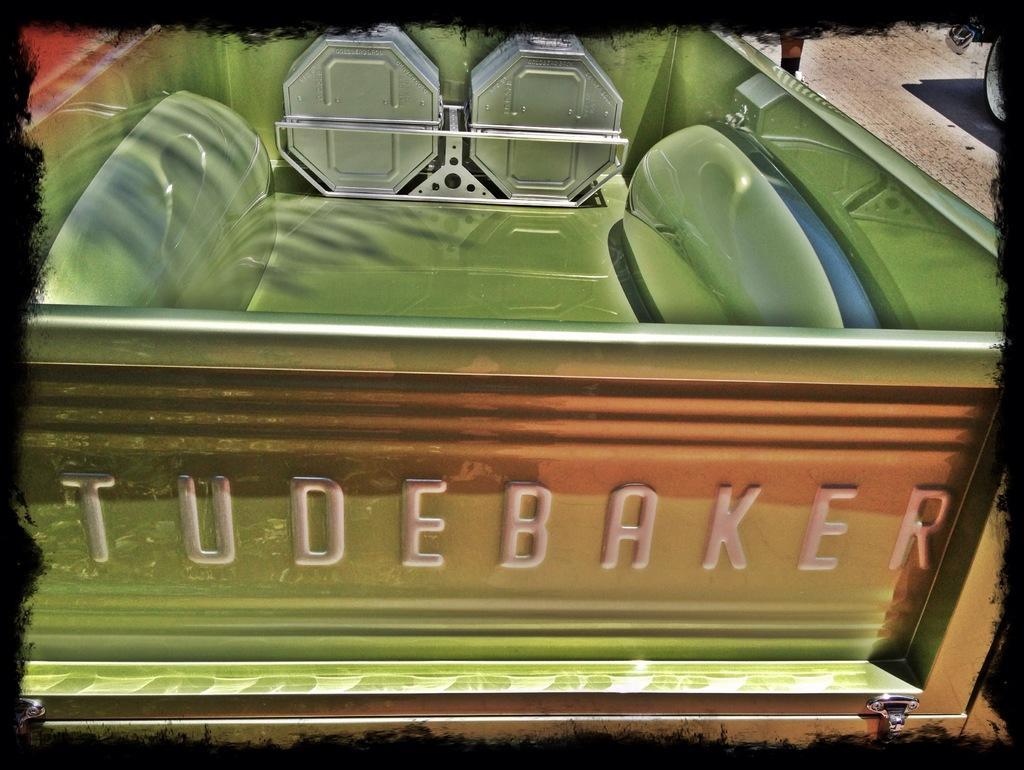Describe this image in one or two sentences. In this image we can see a vehicle, person's leg and a wheel on the ground. This image is edited with a frame. 